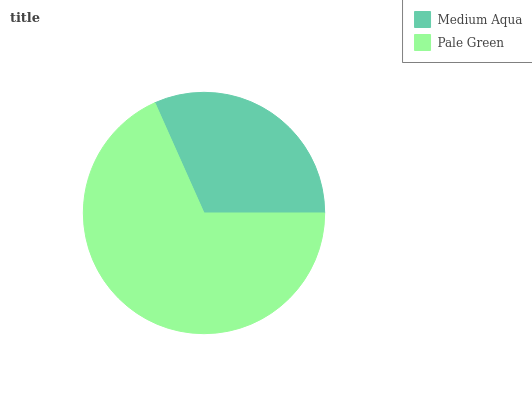Is Medium Aqua the minimum?
Answer yes or no. Yes. Is Pale Green the maximum?
Answer yes or no. Yes. Is Pale Green the minimum?
Answer yes or no. No. Is Pale Green greater than Medium Aqua?
Answer yes or no. Yes. Is Medium Aqua less than Pale Green?
Answer yes or no. Yes. Is Medium Aqua greater than Pale Green?
Answer yes or no. No. Is Pale Green less than Medium Aqua?
Answer yes or no. No. Is Pale Green the high median?
Answer yes or no. Yes. Is Medium Aqua the low median?
Answer yes or no. Yes. Is Medium Aqua the high median?
Answer yes or no. No. Is Pale Green the low median?
Answer yes or no. No. 